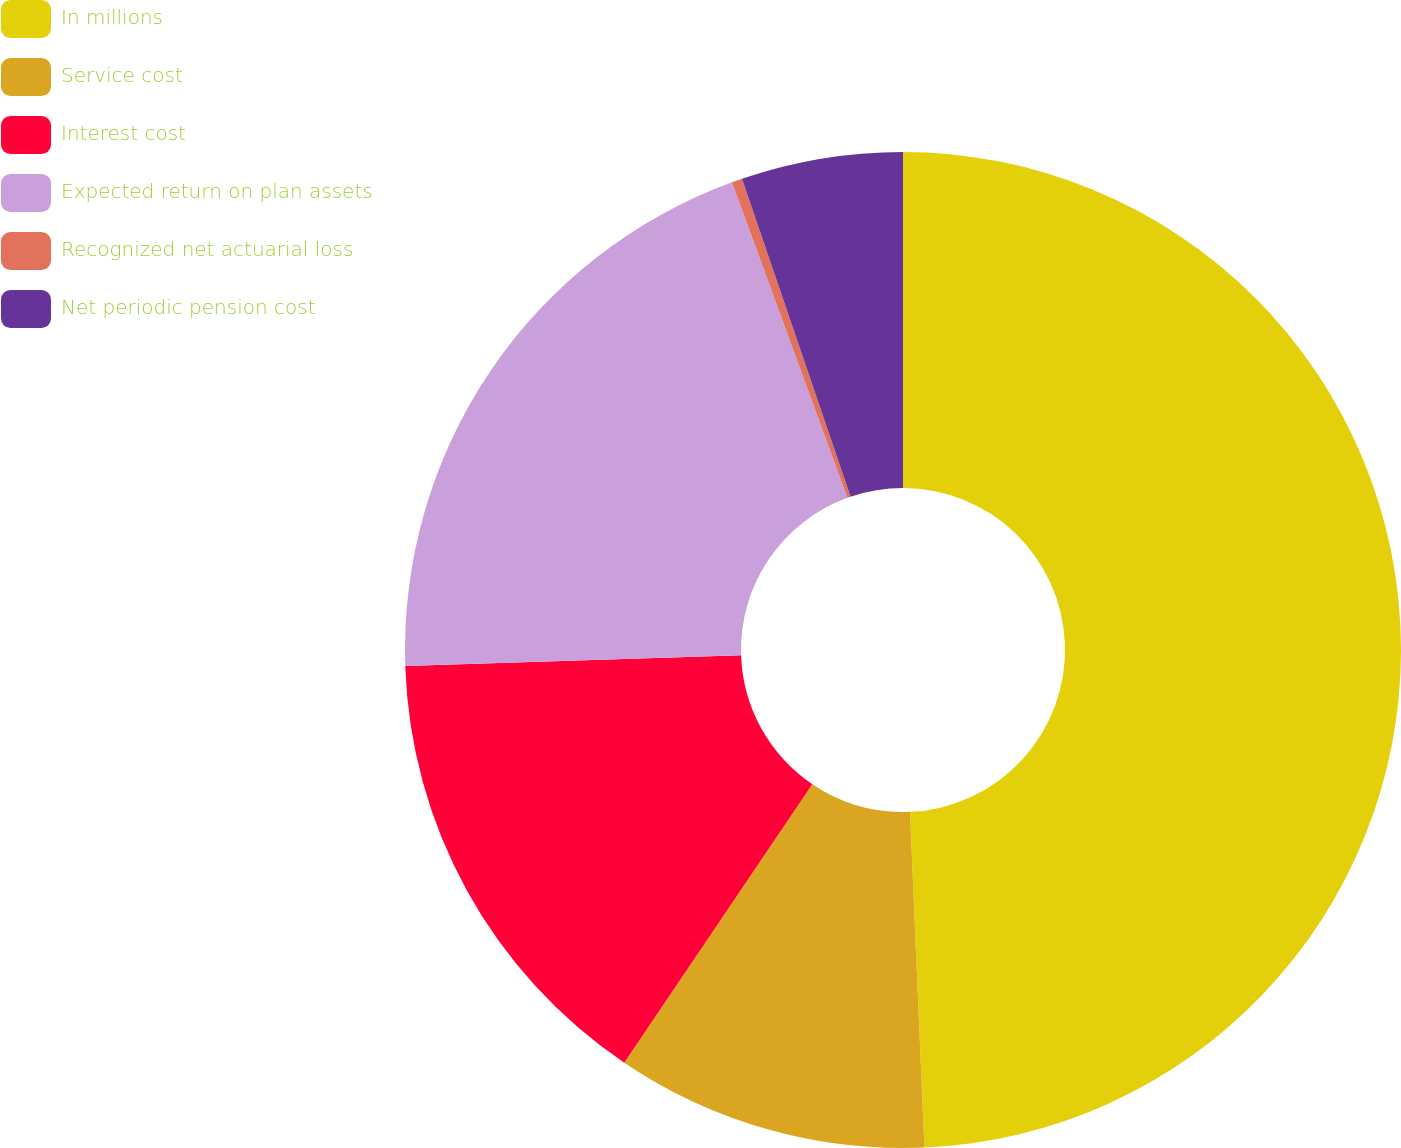Convert chart. <chart><loc_0><loc_0><loc_500><loc_500><pie_chart><fcel>In millions<fcel>Service cost<fcel>Interest cost<fcel>Expected return on plan assets<fcel>Recognized net actuarial loss<fcel>Net periodic pension cost<nl><fcel>49.31%<fcel>10.14%<fcel>15.03%<fcel>19.93%<fcel>0.34%<fcel>5.24%<nl></chart> 